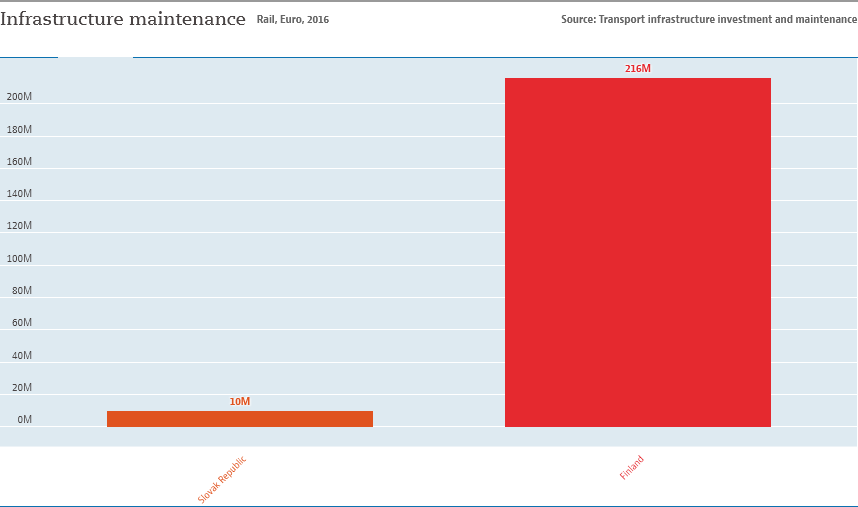List a handful of essential elements in this visual. The color of Finland bar is red. The value of Finland is different from that of the Slovak Republic, which is indicated by the numerical difference of 206. 